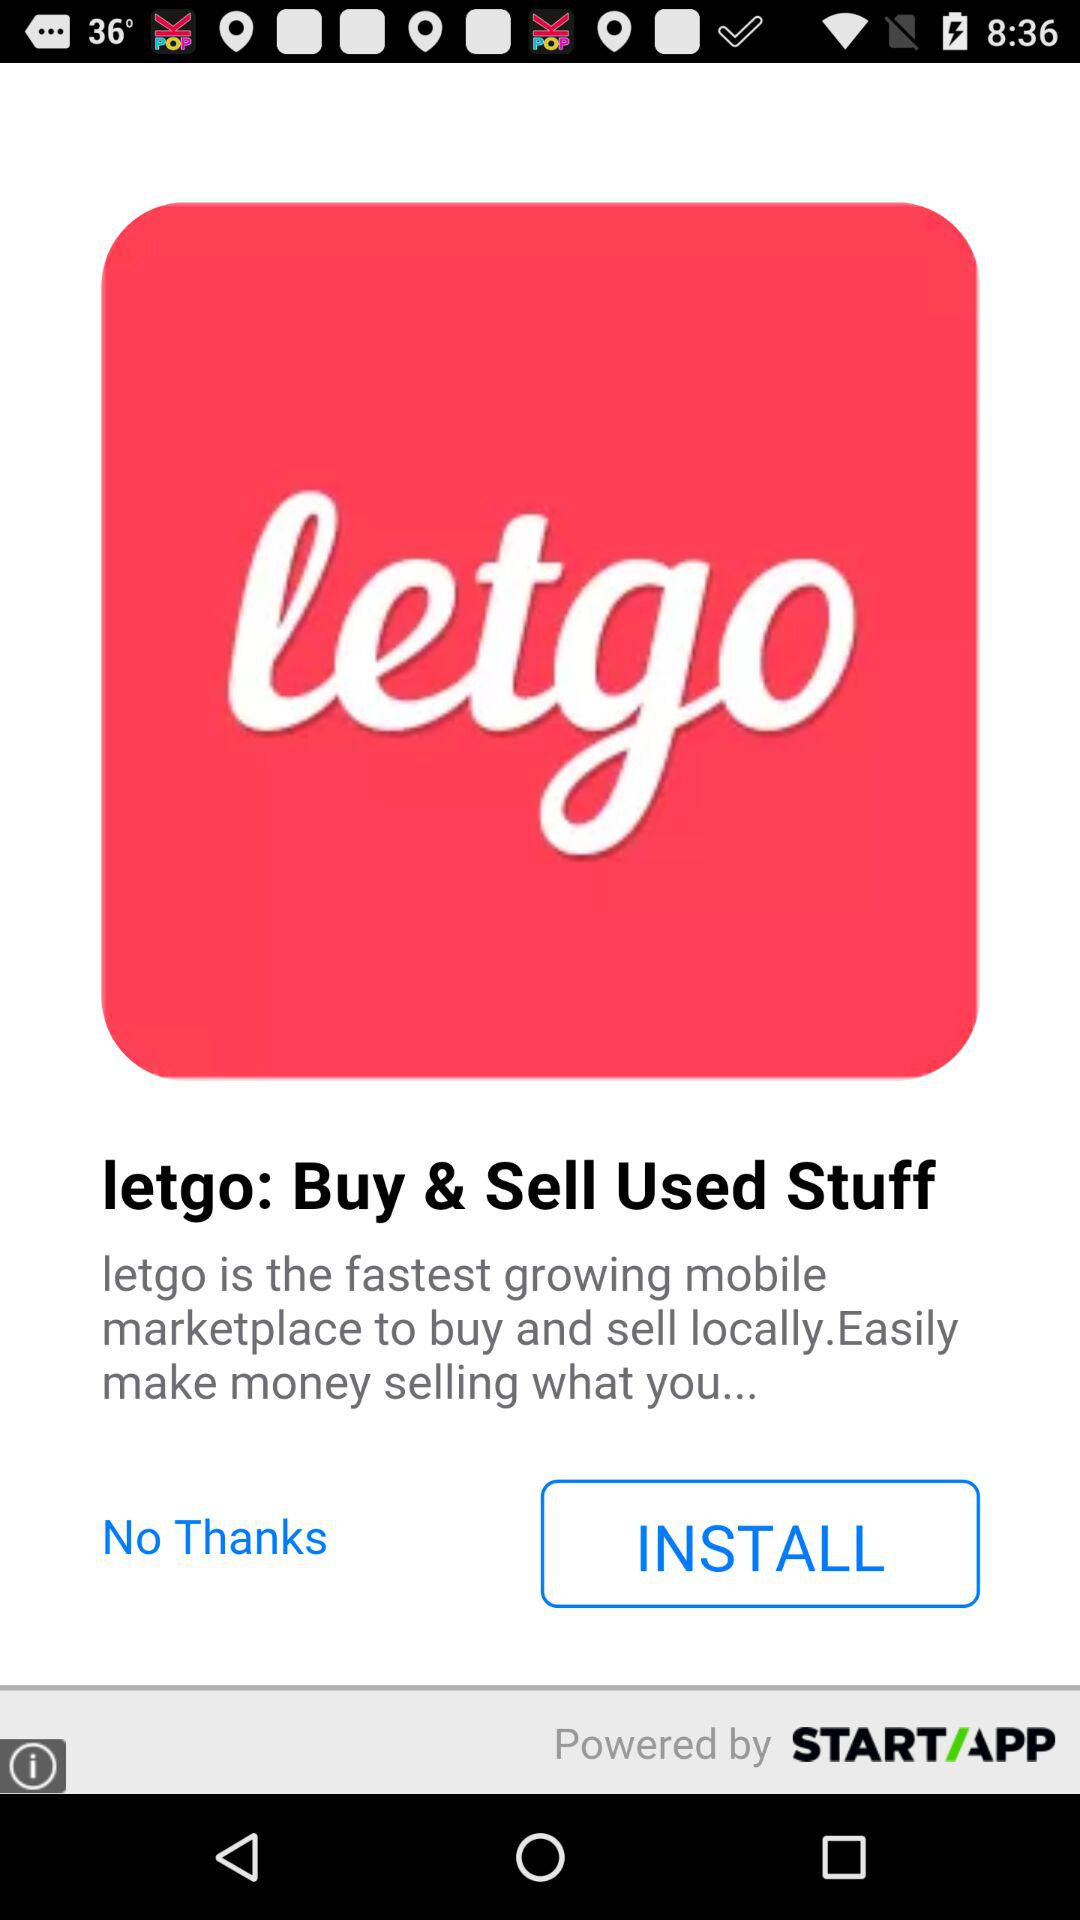What is the application name? The name of the application is "letgo: Buy & Sell Used Stuff". 